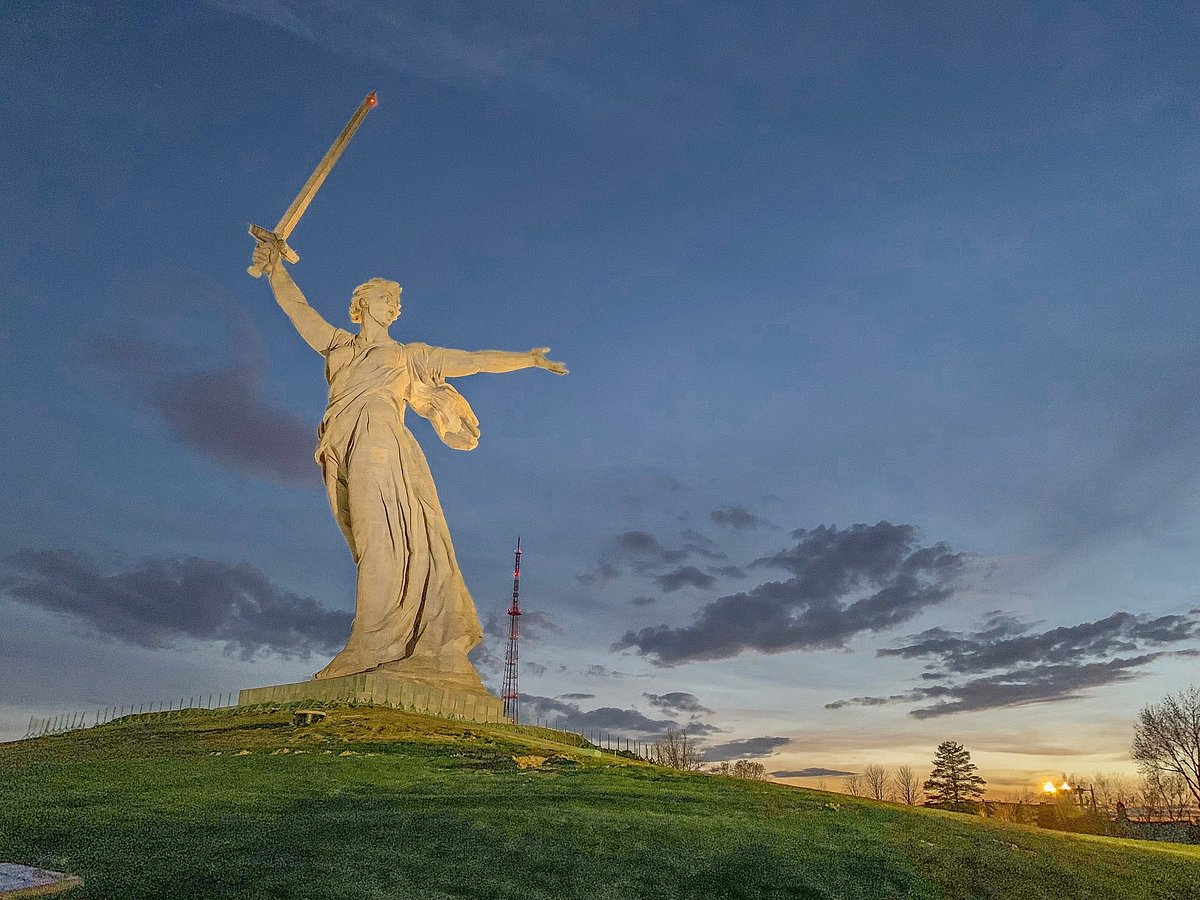What is the significance of the statue depicted in the image? The statue in the image, 'The Motherland Calls,' is a monumental sculpture located in Volgograd, Russia. It was built to commemorate the Battle of Stalingrad during World War II, a pivotal and devastating confrontation between the Soviet Union and Nazi Germany. The statue symbolizes the call to defend the motherland, invoking a sense of patriotism and resilience. Its towering presence and the dynamic pose of the figure embody the spirit of resistance and the determination to overcome adversity. 